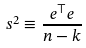Convert formula to latex. <formula><loc_0><loc_0><loc_500><loc_500>s ^ { 2 } \equiv \frac { e ^ { \top } e } { n - k }</formula> 